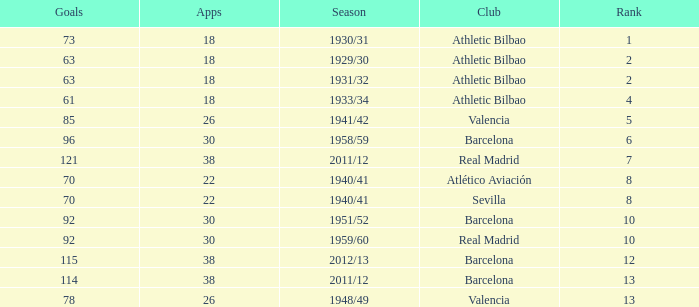What are the apps for less than 61 goals and before rank 6? None. 